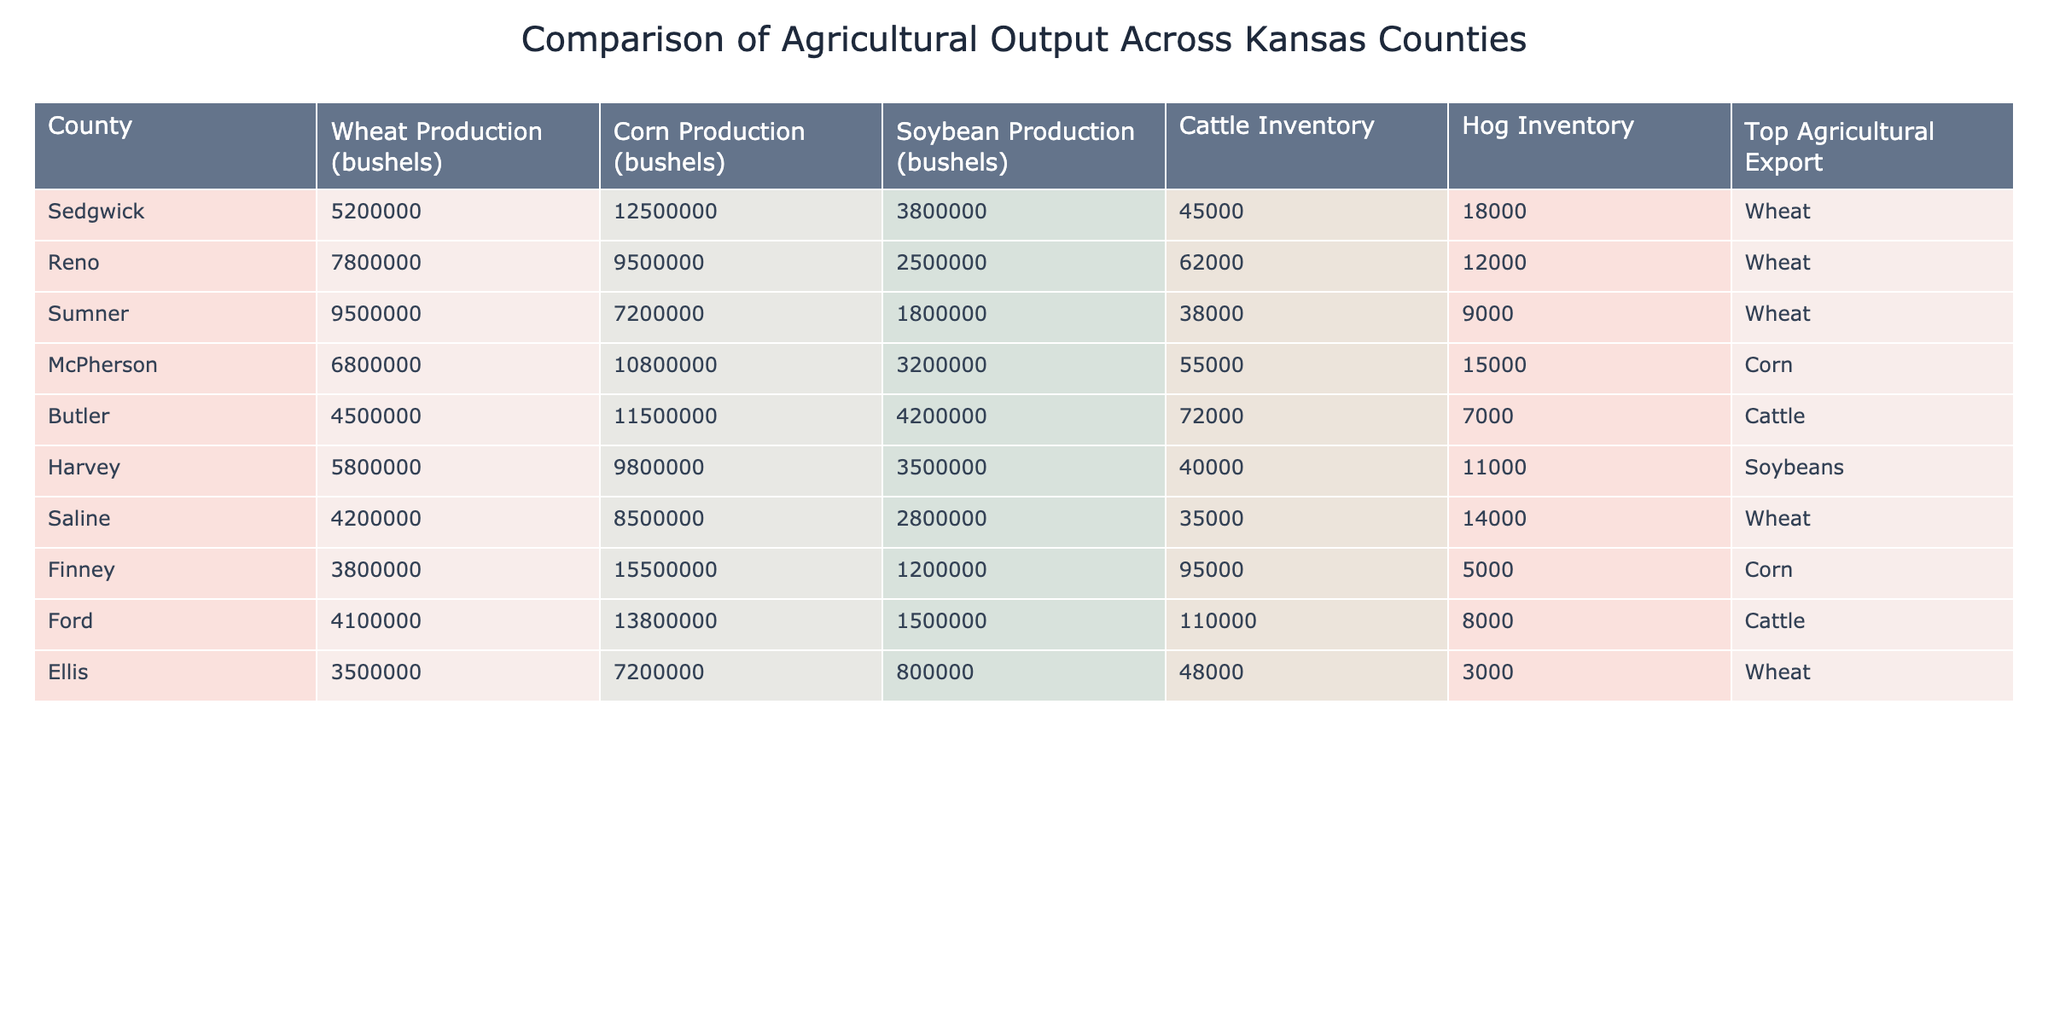What is the total wheat production for all counties listed? To find the total wheat production, I will sum the wheat production values for each county: 5200000 (Sedgwick) + 7800000 (Reno) + 9500000 (Sumner) + 6800000 (McPherson) + 4200000 (Saline) + 3500000 (Ellis) = 32000000
Answer: 32000000 Which county has the highest corn production? Looking at the corn production column, the county with the highest value is Finney with 15500000 bushels.
Answer: Finney Is it true that Butler County has a higher cattle inventory than Sedgwick County? Checking the cattle inventory values, Butler has 72000 compared to Sedgwick's 45000. Thus, Butler has a higher cattle inventory.
Answer: Yes What is the average soybean production of the counties listed? To find the average soybean production, I will sum the soybean production values and divide by the number of counties: (3800000 + 2500000 + 1800000 + 3200000 + 4200000 + 3500000 + 2800000 + 1200000) = 19000000. There are 8 counties, so the average is 19000000 / 8 = 2375000.
Answer: 2375000 Which county has the top agricultural export of soybeans? Referring to the 'Top Agricultural Export' column, Harvey County is listed with soybeans as its primary export.
Answer: Harvey 